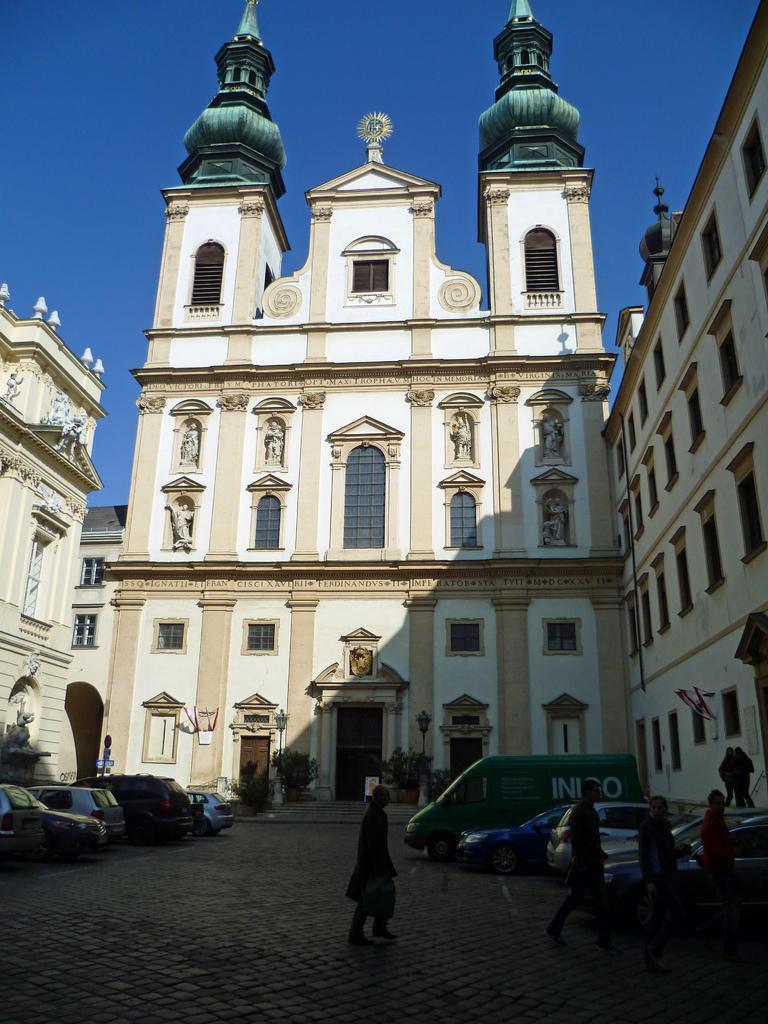Describe this image in one or two sentences. In the center of the image we can see a building, windows, doors are present. At the bottom of the image we can see some persons, trucks, plants, lights, boards are there. At the top of the image sky is there. At the bottom of the image ground is present. 